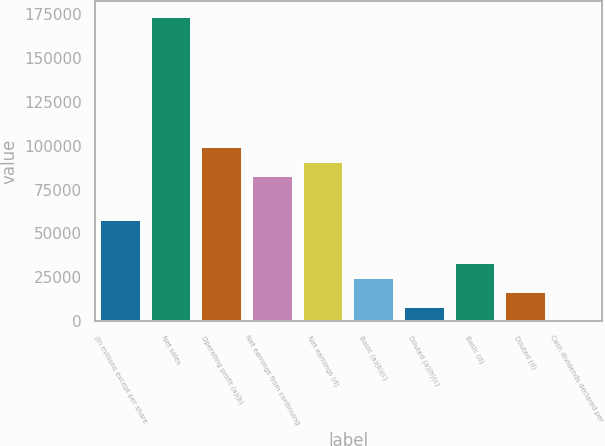Convert chart. <chart><loc_0><loc_0><loc_500><loc_500><bar_chart><fcel>(In millions except per share<fcel>Net sales<fcel>Operating profit (a)(b)<fcel>Net earnings from continuing<fcel>Net earnings (d)<fcel>Basic (a)(b)(c)<fcel>Diluted (a)(b)(c)<fcel>Basic (d)<fcel>Diluted (d)<fcel>Cash dividends declared per<nl><fcel>57821.4<fcel>173455<fcel>99119<fcel>82600<fcel>90859.5<fcel>24783.3<fcel>8264.3<fcel>33042.9<fcel>16523.8<fcel>4.78<nl></chart> 